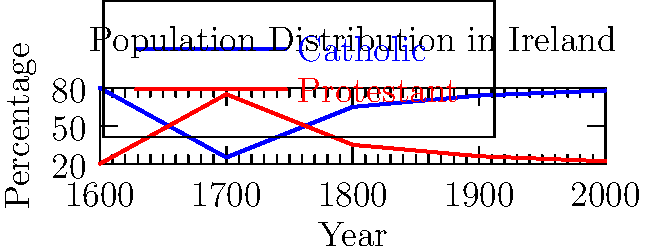Based on the graph showing the distribution of Catholic and Protestant populations in Ireland from 1600 to 2000, which historical event likely caused the most significant shift in the religious demographic between 1600 and 1700? To answer this question, let's analyze the graph step-by-step:

1. In 1600, the Catholic population was approximately 80%, while the Protestant population was about 20%.

2. By 1700, there's a dramatic shift: the Catholic population decreased to about 25%, while the Protestant population increased to roughly 75%.

3. This significant change occurred between 1600 and 1700, which coincides with a major historical event in Irish history: the Plantation of Ulster.

4. The Plantation of Ulster (1609-1690) was a period when the British Crown confiscated land from Irish Catholics and settled it with Protestant colonists from England and Scotland.

5. This policy was designed to establish a Protestant majority in Ulster and strengthen British control over Ireland.

6. The graph clearly shows the impact of this policy, with a near-complete reversal of the religious demographic in just one century.

7. No other period in the graph shows such a dramatic shift in religious demographics, making the Plantation of Ulster the most likely cause of this change.

8. After 1700, we see a gradual return to a Catholic majority, but never reaching the pre-1600 levels, reflecting the long-term impact of the Plantation system.
Answer: The Plantation of Ulster 